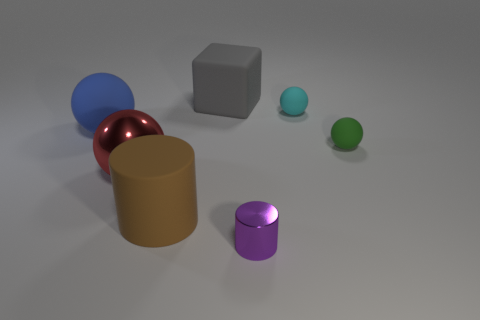Add 2 big things. How many objects exist? 9 Subtract all cylinders. How many objects are left? 5 Subtract all brown cylinders. Subtract all purple cylinders. How many objects are left? 5 Add 6 shiny objects. How many shiny objects are left? 8 Add 3 big gray blocks. How many big gray blocks exist? 4 Subtract 0 green cylinders. How many objects are left? 7 